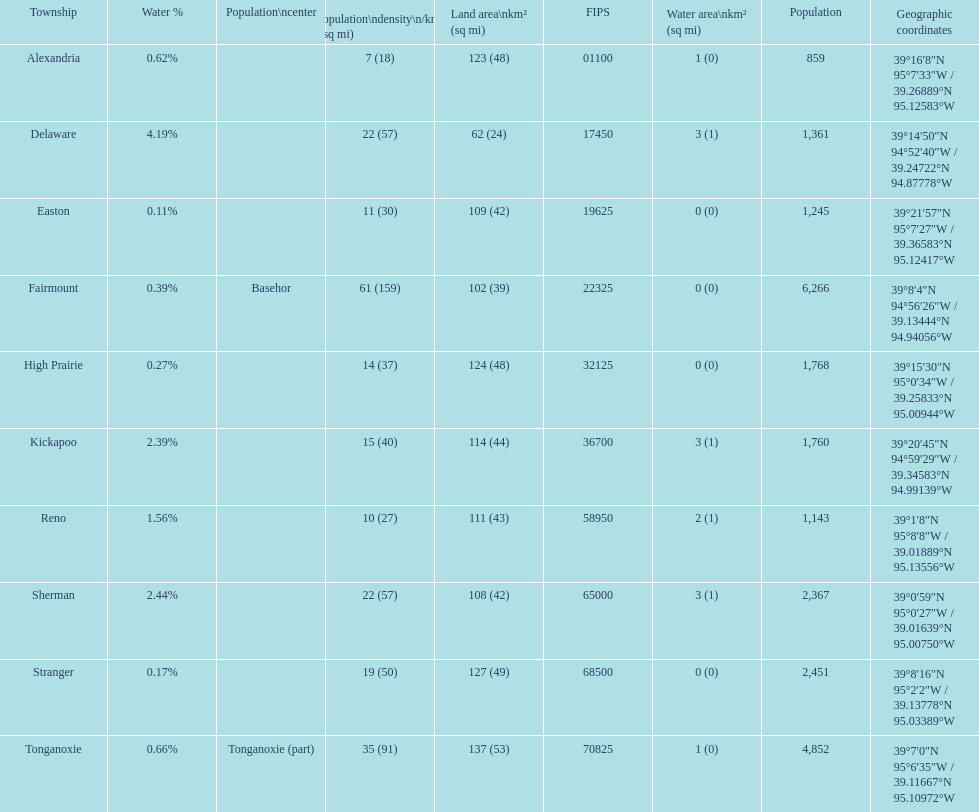I'm looking to parse the entire table for insights. Could you assist me with that? {'header': ['Township', 'Water\xa0%', 'Population\\ncenter', 'Population\\ndensity\\n/km² (/sq\xa0mi)', 'Land area\\nkm² (sq\xa0mi)', 'FIPS', 'Water area\\nkm² (sq\xa0mi)', 'Population', 'Geographic coordinates'], 'rows': [['Alexandria', '0.62%', '', '7 (18)', '123 (48)', '01100', '1 (0)', '859', '39°16′8″N 95°7′33″W\ufeff / \ufeff39.26889°N 95.12583°W'], ['Delaware', '4.19%', '', '22 (57)', '62 (24)', '17450', '3 (1)', '1,361', '39°14′50″N 94°52′40″W\ufeff / \ufeff39.24722°N 94.87778°W'], ['Easton', '0.11%', '', '11 (30)', '109 (42)', '19625', '0 (0)', '1,245', '39°21′57″N 95°7′27″W\ufeff / \ufeff39.36583°N 95.12417°W'], ['Fairmount', '0.39%', 'Basehor', '61 (159)', '102 (39)', '22325', '0 (0)', '6,266', '39°8′4″N 94°56′26″W\ufeff / \ufeff39.13444°N 94.94056°W'], ['High Prairie', '0.27%', '', '14 (37)', '124 (48)', '32125', '0 (0)', '1,768', '39°15′30″N 95°0′34″W\ufeff / \ufeff39.25833°N 95.00944°W'], ['Kickapoo', '2.39%', '', '15 (40)', '114 (44)', '36700', '3 (1)', '1,760', '39°20′45″N 94°59′29″W\ufeff / \ufeff39.34583°N 94.99139°W'], ['Reno', '1.56%', '', '10 (27)', '111 (43)', '58950', '2 (1)', '1,143', '39°1′8″N 95°8′8″W\ufeff / \ufeff39.01889°N 95.13556°W'], ['Sherman', '2.44%', '', '22 (57)', '108 (42)', '65000', '3 (1)', '2,367', '39°0′59″N 95°0′27″W\ufeff / \ufeff39.01639°N 95.00750°W'], ['Stranger', '0.17%', '', '19 (50)', '127 (49)', '68500', '0 (0)', '2,451', '39°8′16″N 95°2′2″W\ufeff / \ufeff39.13778°N 95.03389°W'], ['Tonganoxie', '0.66%', 'Tonganoxie (part)', '35 (91)', '137 (53)', '70825', '1 (0)', '4,852', '39°7′0″N 95°6′35″W\ufeff / \ufeff39.11667°N 95.10972°W']]} What is the number of townships with a population larger than 2,000? 4. 